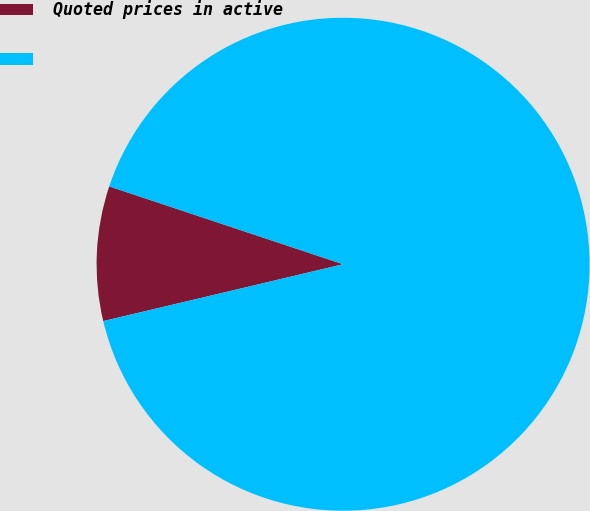Convert chart to OTSL. <chart><loc_0><loc_0><loc_500><loc_500><pie_chart><fcel>Quoted prices in active<fcel>Unnamed: 1<nl><fcel>8.82%<fcel>91.18%<nl></chart> 